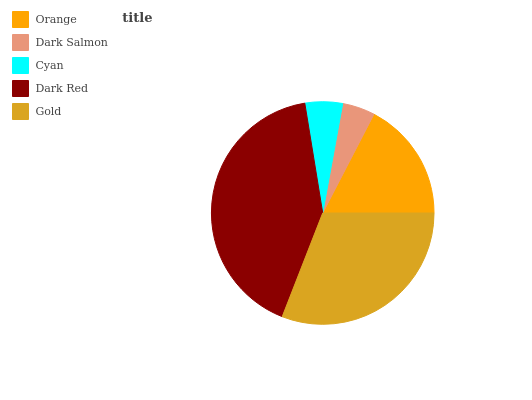Is Dark Salmon the minimum?
Answer yes or no. Yes. Is Dark Red the maximum?
Answer yes or no. Yes. Is Cyan the minimum?
Answer yes or no. No. Is Cyan the maximum?
Answer yes or no. No. Is Cyan greater than Dark Salmon?
Answer yes or no. Yes. Is Dark Salmon less than Cyan?
Answer yes or no. Yes. Is Dark Salmon greater than Cyan?
Answer yes or no. No. Is Cyan less than Dark Salmon?
Answer yes or no. No. Is Orange the high median?
Answer yes or no. Yes. Is Orange the low median?
Answer yes or no. Yes. Is Gold the high median?
Answer yes or no. No. Is Dark Salmon the low median?
Answer yes or no. No. 